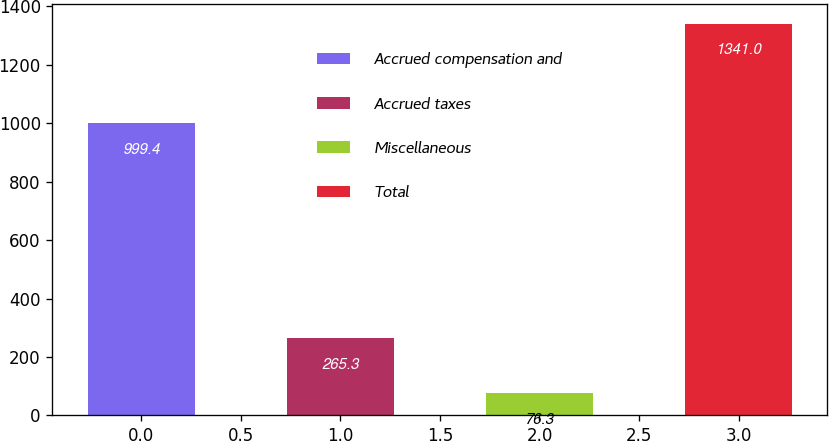Convert chart. <chart><loc_0><loc_0><loc_500><loc_500><bar_chart><fcel>Accrued compensation and<fcel>Accrued taxes<fcel>Miscellaneous<fcel>Total<nl><fcel>999.4<fcel>265.3<fcel>76.3<fcel>1341<nl></chart> 